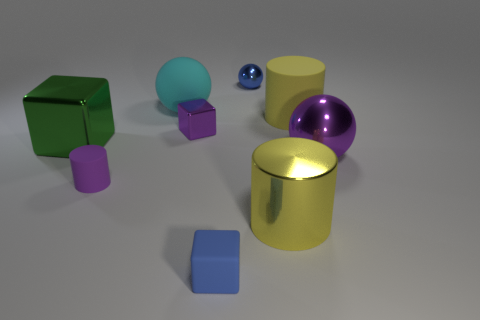Add 1 tiny blue objects. How many objects exist? 10 Subtract all cylinders. How many objects are left? 6 Subtract all small brown matte things. Subtract all large cyan matte objects. How many objects are left? 8 Add 2 large yellow matte things. How many large yellow matte things are left? 3 Add 1 big brown matte cylinders. How many big brown matte cylinders exist? 1 Subtract 1 purple balls. How many objects are left? 8 